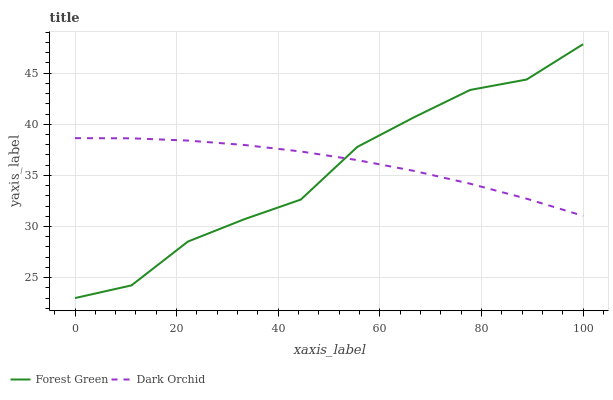Does Forest Green have the minimum area under the curve?
Answer yes or no. Yes. Does Dark Orchid have the maximum area under the curve?
Answer yes or no. Yes. Does Dark Orchid have the minimum area under the curve?
Answer yes or no. No. Is Dark Orchid the smoothest?
Answer yes or no. Yes. Is Forest Green the roughest?
Answer yes or no. Yes. Is Dark Orchid the roughest?
Answer yes or no. No. Does Dark Orchid have the lowest value?
Answer yes or no. No. Does Forest Green have the highest value?
Answer yes or no. Yes. Does Dark Orchid have the highest value?
Answer yes or no. No. Does Dark Orchid intersect Forest Green?
Answer yes or no. Yes. Is Dark Orchid less than Forest Green?
Answer yes or no. No. Is Dark Orchid greater than Forest Green?
Answer yes or no. No. 